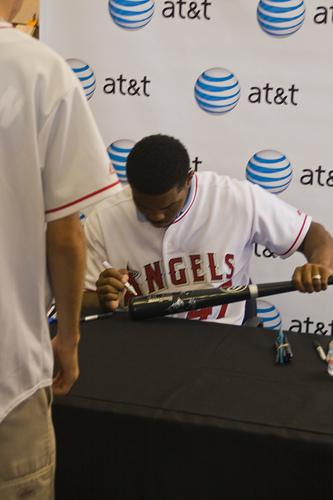What is the seated man's profession?

Choices:
A) athlete
B) dentist
C) teacher
D) doctor athlete 